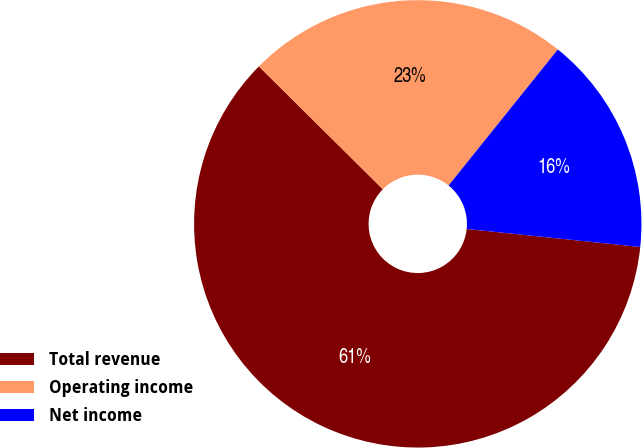Convert chart. <chart><loc_0><loc_0><loc_500><loc_500><pie_chart><fcel>Total revenue<fcel>Operating income<fcel>Net income<nl><fcel>60.78%<fcel>23.34%<fcel>15.88%<nl></chart> 